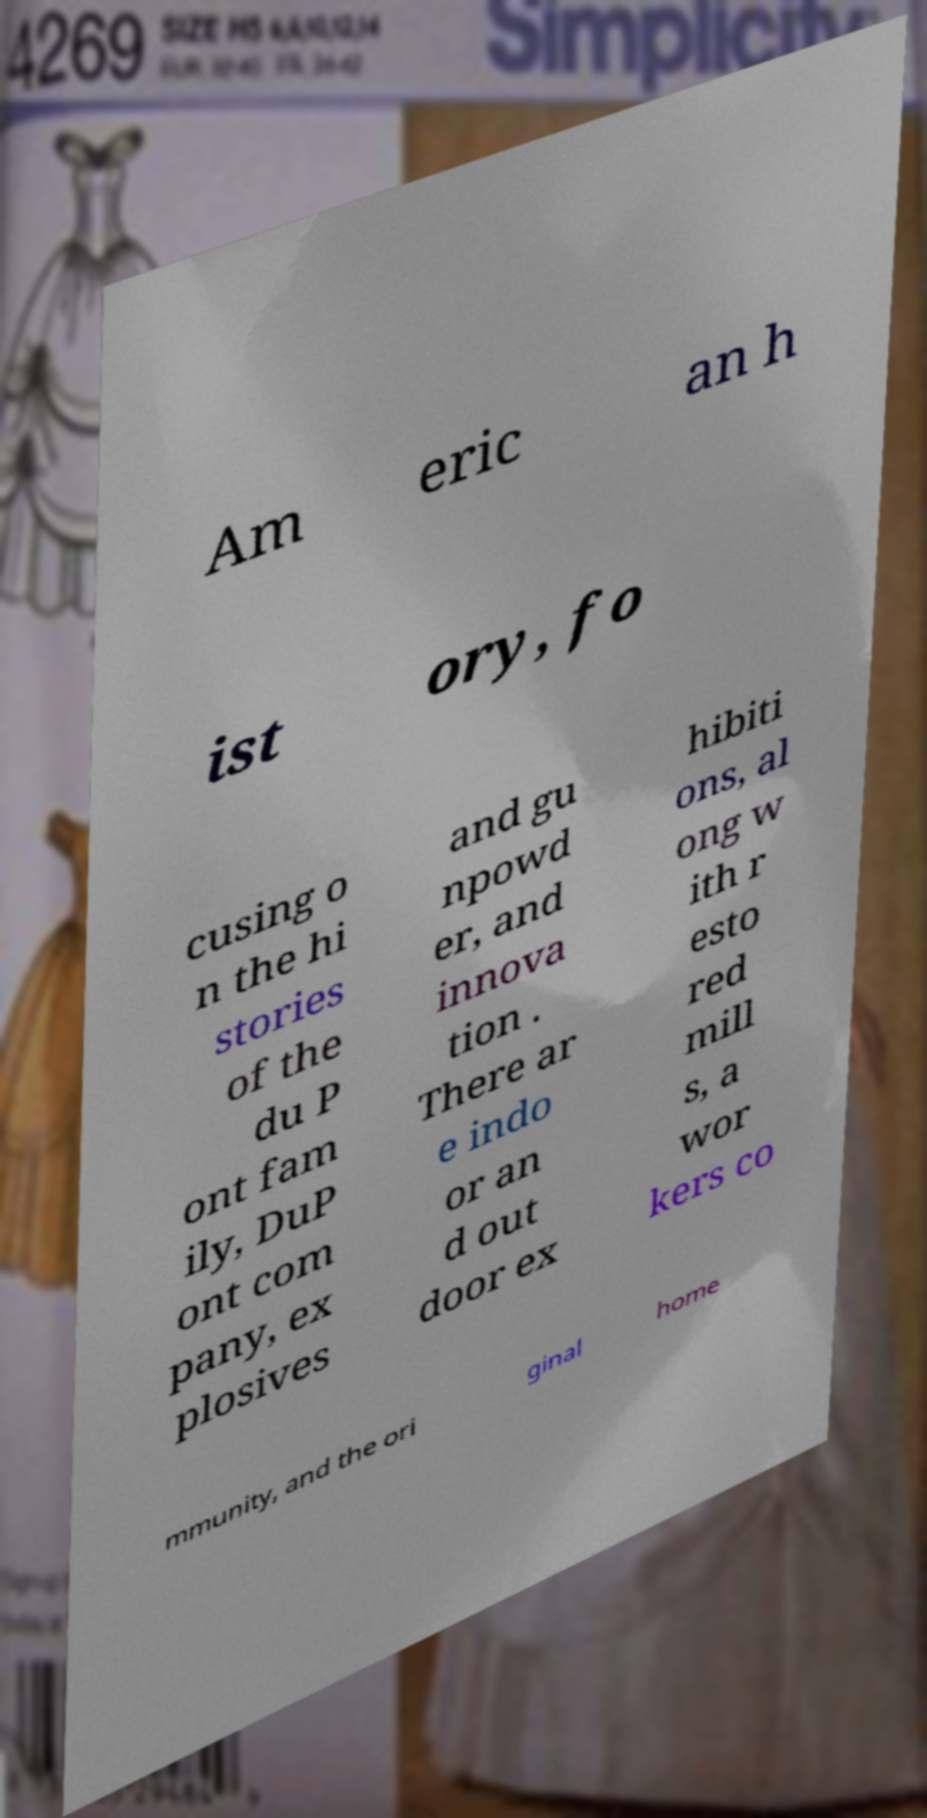There's text embedded in this image that I need extracted. Can you transcribe it verbatim? Am eric an h ist ory, fo cusing o n the hi stories of the du P ont fam ily, DuP ont com pany, ex plosives and gu npowd er, and innova tion . There ar e indo or an d out door ex hibiti ons, al ong w ith r esto red mill s, a wor kers co mmunity, and the ori ginal home 